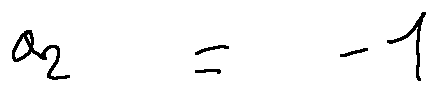Convert formula to latex. <formula><loc_0><loc_0><loc_500><loc_500>a _ { 2 } = - 1</formula> 